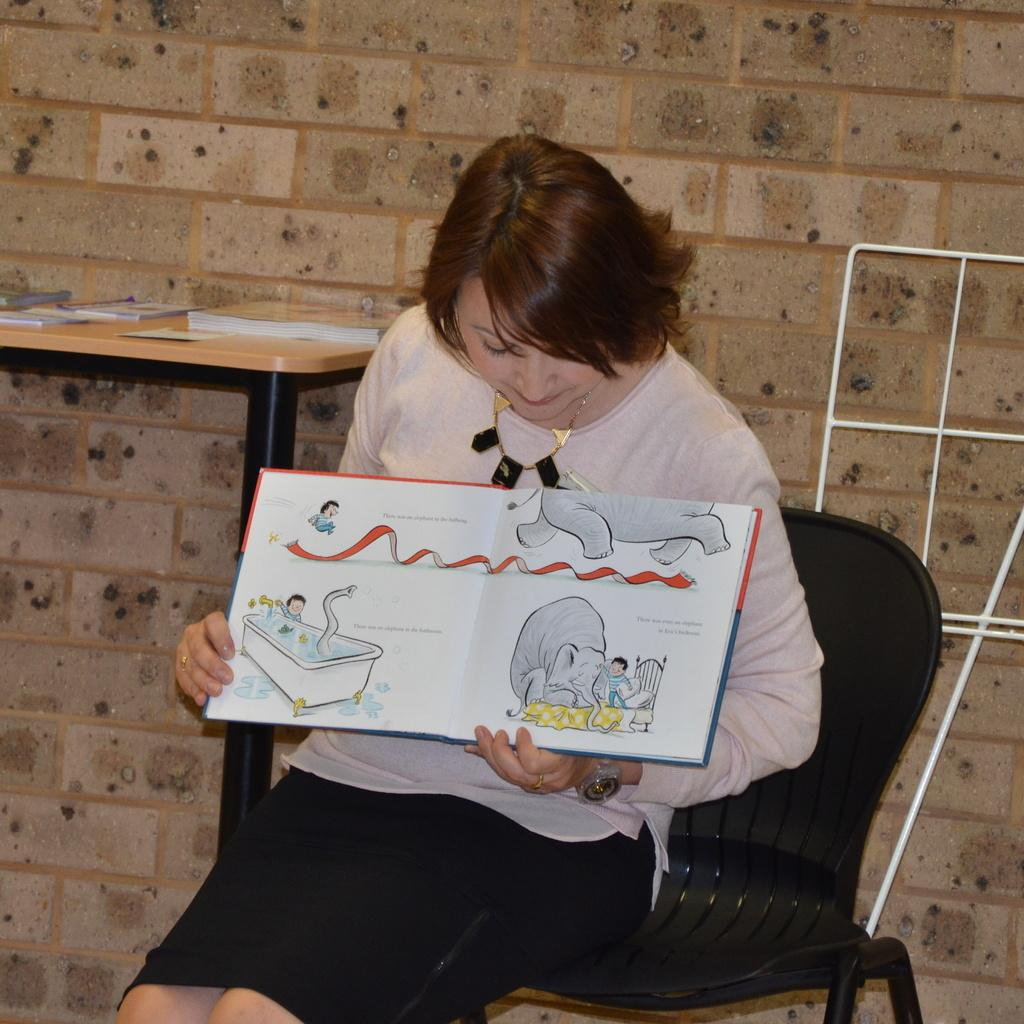What is the woman doing in the image? She is sitting on a chair and holding a book. What can be seen in the background of the image? There is a table and a wall in the background. Can you describe the woman's activity in the image? She is sitting on a chair and appears to be reading or holding a book. How many cows are visible in the image? There are no cows present in the image. What type of machine is being used by the woman in the image? There is no machine visible in the image; the woman is simply sitting on a chair and holding a book. 